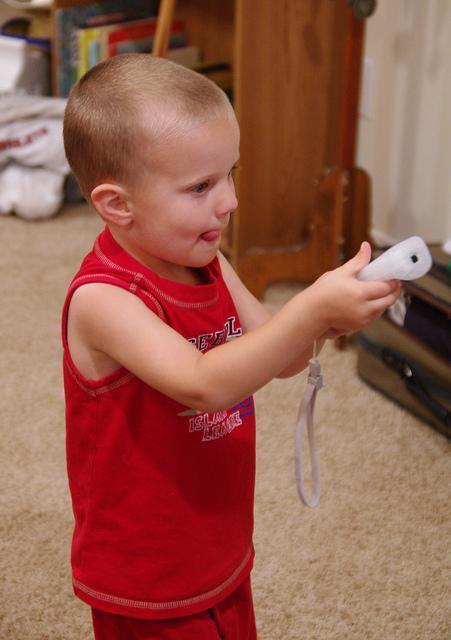How many pieces of chocolate cake are on the white plate?
Give a very brief answer. 0. 